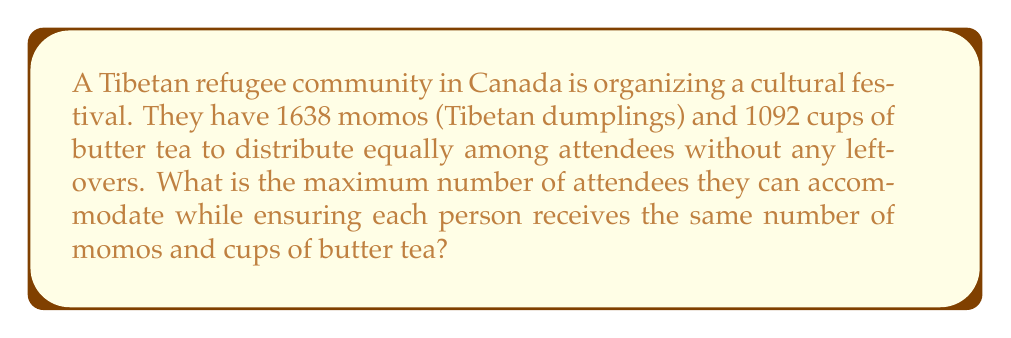Teach me how to tackle this problem. To solve this problem, we need to find the greatest common divisor (GCD) of 1638 and 1092 using the Euclidean algorithm. This will give us the largest number that divides both quantities evenly.

Let's apply the Euclidean algorithm:

1) First, divide 1638 by 1092:
   $$1638 = 1 \times 1092 + 546$$

2) Now, divide 1092 by 546:
   $$1092 = 2 \times 546 + 0$$

3) The process stops here as we've reached a remainder of 0.

4) The last non-zero remainder is 546, which is our GCD.

Therefore, the GCD of 1638 and 1092 is 546.

This means that 546 is the maximum number of attendees that can be accommodated, with each person receiving:

- Number of momos per person: $1638 \div 546 = 3$
- Cups of butter tea per person: $1092 \div 546 = 2$
Answer: 546 